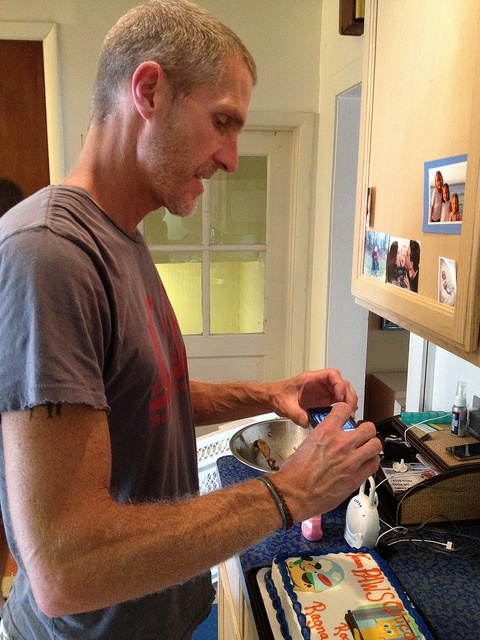Describe the objects in this image and their specific colors. I can see people in tan, maroon, brown, and black tones, cake in tan and black tones, bowl in tan, gray, maroon, and darkgray tones, and cell phone in tan, black, navy, lightblue, and maroon tones in this image. 